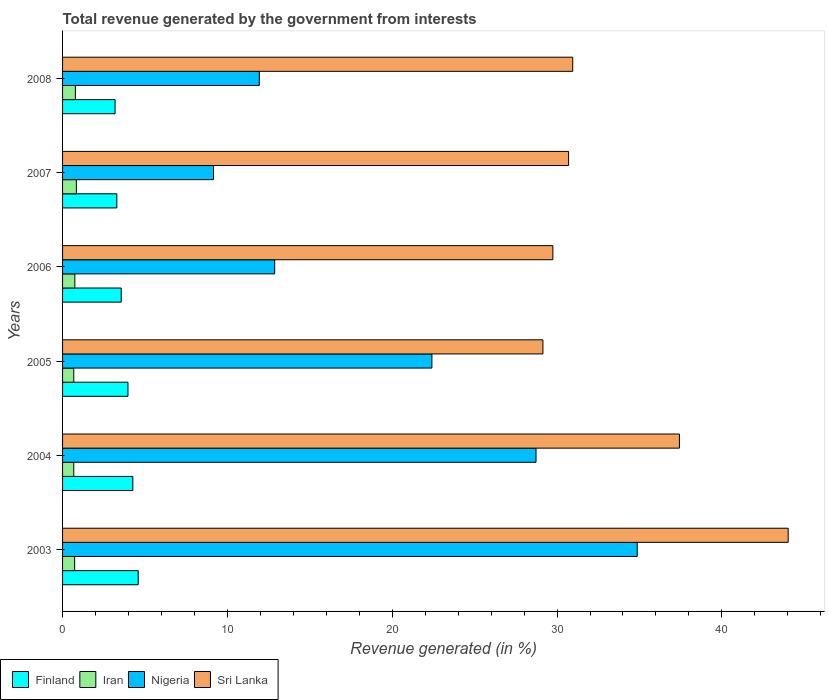How many different coloured bars are there?
Keep it short and to the point. 4. Are the number of bars on each tick of the Y-axis equal?
Give a very brief answer. Yes. How many bars are there on the 1st tick from the bottom?
Provide a short and direct response. 4. What is the total revenue generated in Nigeria in 2007?
Keep it short and to the point. 9.16. Across all years, what is the maximum total revenue generated in Iran?
Offer a terse response. 0.84. Across all years, what is the minimum total revenue generated in Nigeria?
Keep it short and to the point. 9.16. What is the total total revenue generated in Nigeria in the graph?
Offer a very short reply. 119.96. What is the difference between the total revenue generated in Sri Lanka in 2006 and that in 2008?
Your answer should be compact. -1.21. What is the difference between the total revenue generated in Nigeria in 2005 and the total revenue generated in Iran in 2003?
Your response must be concise. 21.67. What is the average total revenue generated in Nigeria per year?
Your response must be concise. 19.99. In the year 2006, what is the difference between the total revenue generated in Nigeria and total revenue generated in Finland?
Your response must be concise. 9.31. In how many years, is the total revenue generated in Nigeria greater than 8 %?
Keep it short and to the point. 6. What is the ratio of the total revenue generated in Finland in 2003 to that in 2005?
Keep it short and to the point. 1.16. Is the total revenue generated in Nigeria in 2004 less than that in 2008?
Provide a short and direct response. No. What is the difference between the highest and the second highest total revenue generated in Iran?
Make the answer very short. 0.06. What is the difference between the highest and the lowest total revenue generated in Finland?
Provide a succinct answer. 1.4. Is the sum of the total revenue generated in Sri Lanka in 2003 and 2007 greater than the maximum total revenue generated in Finland across all years?
Your response must be concise. Yes. Is it the case that in every year, the sum of the total revenue generated in Iran and total revenue generated in Finland is greater than the sum of total revenue generated in Sri Lanka and total revenue generated in Nigeria?
Provide a short and direct response. No. What does the 2nd bar from the top in 2008 represents?
Provide a succinct answer. Nigeria. How many bars are there?
Offer a very short reply. 24. Are all the bars in the graph horizontal?
Give a very brief answer. Yes. How many years are there in the graph?
Your response must be concise. 6. What is the title of the graph?
Offer a terse response. Total revenue generated by the government from interests. Does "Chile" appear as one of the legend labels in the graph?
Offer a terse response. No. What is the label or title of the X-axis?
Give a very brief answer. Revenue generated (in %). What is the label or title of the Y-axis?
Give a very brief answer. Years. What is the Revenue generated (in %) of Finland in 2003?
Provide a succinct answer. 4.59. What is the Revenue generated (in %) in Iran in 2003?
Offer a terse response. 0.73. What is the Revenue generated (in %) of Nigeria in 2003?
Your response must be concise. 34.86. What is the Revenue generated (in %) of Sri Lanka in 2003?
Ensure brevity in your answer.  44.02. What is the Revenue generated (in %) in Finland in 2004?
Provide a short and direct response. 4.26. What is the Revenue generated (in %) of Iran in 2004?
Provide a succinct answer. 0.68. What is the Revenue generated (in %) of Nigeria in 2004?
Ensure brevity in your answer.  28.72. What is the Revenue generated (in %) of Sri Lanka in 2004?
Offer a very short reply. 37.43. What is the Revenue generated (in %) in Finland in 2005?
Make the answer very short. 3.97. What is the Revenue generated (in %) in Iran in 2005?
Give a very brief answer. 0.68. What is the Revenue generated (in %) in Nigeria in 2005?
Your answer should be very brief. 22.41. What is the Revenue generated (in %) of Sri Lanka in 2005?
Give a very brief answer. 29.14. What is the Revenue generated (in %) of Finland in 2006?
Your answer should be very brief. 3.56. What is the Revenue generated (in %) in Iran in 2006?
Provide a succinct answer. 0.75. What is the Revenue generated (in %) in Nigeria in 2006?
Give a very brief answer. 12.87. What is the Revenue generated (in %) in Sri Lanka in 2006?
Your answer should be compact. 29.75. What is the Revenue generated (in %) in Finland in 2007?
Give a very brief answer. 3.29. What is the Revenue generated (in %) of Iran in 2007?
Offer a very short reply. 0.84. What is the Revenue generated (in %) of Nigeria in 2007?
Your answer should be compact. 9.16. What is the Revenue generated (in %) in Sri Lanka in 2007?
Your response must be concise. 30.7. What is the Revenue generated (in %) in Finland in 2008?
Offer a very short reply. 3.19. What is the Revenue generated (in %) in Iran in 2008?
Offer a terse response. 0.78. What is the Revenue generated (in %) of Nigeria in 2008?
Your answer should be compact. 11.94. What is the Revenue generated (in %) in Sri Lanka in 2008?
Provide a short and direct response. 30.95. Across all years, what is the maximum Revenue generated (in %) of Finland?
Ensure brevity in your answer.  4.59. Across all years, what is the maximum Revenue generated (in %) in Iran?
Your answer should be very brief. 0.84. Across all years, what is the maximum Revenue generated (in %) in Nigeria?
Provide a short and direct response. 34.86. Across all years, what is the maximum Revenue generated (in %) in Sri Lanka?
Offer a very short reply. 44.02. Across all years, what is the minimum Revenue generated (in %) of Finland?
Give a very brief answer. 3.19. Across all years, what is the minimum Revenue generated (in %) in Iran?
Your answer should be compact. 0.68. Across all years, what is the minimum Revenue generated (in %) of Nigeria?
Ensure brevity in your answer.  9.16. Across all years, what is the minimum Revenue generated (in %) of Sri Lanka?
Give a very brief answer. 29.14. What is the total Revenue generated (in %) of Finland in the graph?
Your response must be concise. 22.86. What is the total Revenue generated (in %) in Iran in the graph?
Offer a terse response. 4.45. What is the total Revenue generated (in %) in Nigeria in the graph?
Your answer should be compact. 119.96. What is the total Revenue generated (in %) of Sri Lanka in the graph?
Make the answer very short. 201.99. What is the difference between the Revenue generated (in %) of Finland in 2003 and that in 2004?
Your answer should be compact. 0.33. What is the difference between the Revenue generated (in %) of Iran in 2003 and that in 2004?
Give a very brief answer. 0.05. What is the difference between the Revenue generated (in %) of Nigeria in 2003 and that in 2004?
Ensure brevity in your answer.  6.14. What is the difference between the Revenue generated (in %) of Sri Lanka in 2003 and that in 2004?
Give a very brief answer. 6.6. What is the difference between the Revenue generated (in %) of Finland in 2003 and that in 2005?
Keep it short and to the point. 0.62. What is the difference between the Revenue generated (in %) of Iran in 2003 and that in 2005?
Provide a short and direct response. 0.05. What is the difference between the Revenue generated (in %) in Nigeria in 2003 and that in 2005?
Your answer should be very brief. 12.46. What is the difference between the Revenue generated (in %) of Sri Lanka in 2003 and that in 2005?
Provide a short and direct response. 14.88. What is the difference between the Revenue generated (in %) in Finland in 2003 and that in 2006?
Your response must be concise. 1.03. What is the difference between the Revenue generated (in %) of Iran in 2003 and that in 2006?
Provide a short and direct response. -0.01. What is the difference between the Revenue generated (in %) of Nigeria in 2003 and that in 2006?
Your response must be concise. 22. What is the difference between the Revenue generated (in %) of Sri Lanka in 2003 and that in 2006?
Your answer should be compact. 14.28. What is the difference between the Revenue generated (in %) in Finland in 2003 and that in 2007?
Your answer should be very brief. 1.3. What is the difference between the Revenue generated (in %) in Iran in 2003 and that in 2007?
Provide a succinct answer. -0.1. What is the difference between the Revenue generated (in %) in Nigeria in 2003 and that in 2007?
Your answer should be very brief. 25.71. What is the difference between the Revenue generated (in %) in Sri Lanka in 2003 and that in 2007?
Your answer should be compact. 13.32. What is the difference between the Revenue generated (in %) of Finland in 2003 and that in 2008?
Offer a terse response. 1.4. What is the difference between the Revenue generated (in %) of Iran in 2003 and that in 2008?
Offer a very short reply. -0.04. What is the difference between the Revenue generated (in %) of Nigeria in 2003 and that in 2008?
Your response must be concise. 22.93. What is the difference between the Revenue generated (in %) in Sri Lanka in 2003 and that in 2008?
Offer a terse response. 13.07. What is the difference between the Revenue generated (in %) in Finland in 2004 and that in 2005?
Give a very brief answer. 0.29. What is the difference between the Revenue generated (in %) of Iran in 2004 and that in 2005?
Provide a succinct answer. 0. What is the difference between the Revenue generated (in %) of Nigeria in 2004 and that in 2005?
Your answer should be very brief. 6.32. What is the difference between the Revenue generated (in %) of Sri Lanka in 2004 and that in 2005?
Make the answer very short. 8.28. What is the difference between the Revenue generated (in %) in Finland in 2004 and that in 2006?
Give a very brief answer. 0.7. What is the difference between the Revenue generated (in %) of Iran in 2004 and that in 2006?
Make the answer very short. -0.06. What is the difference between the Revenue generated (in %) in Nigeria in 2004 and that in 2006?
Provide a succinct answer. 15.86. What is the difference between the Revenue generated (in %) of Sri Lanka in 2004 and that in 2006?
Your answer should be very brief. 7.68. What is the difference between the Revenue generated (in %) in Finland in 2004 and that in 2007?
Ensure brevity in your answer.  0.97. What is the difference between the Revenue generated (in %) of Iran in 2004 and that in 2007?
Make the answer very short. -0.16. What is the difference between the Revenue generated (in %) of Nigeria in 2004 and that in 2007?
Your response must be concise. 19.57. What is the difference between the Revenue generated (in %) in Sri Lanka in 2004 and that in 2007?
Your response must be concise. 6.72. What is the difference between the Revenue generated (in %) in Finland in 2004 and that in 2008?
Ensure brevity in your answer.  1.08. What is the difference between the Revenue generated (in %) in Iran in 2004 and that in 2008?
Ensure brevity in your answer.  -0.1. What is the difference between the Revenue generated (in %) of Nigeria in 2004 and that in 2008?
Make the answer very short. 16.79. What is the difference between the Revenue generated (in %) of Sri Lanka in 2004 and that in 2008?
Give a very brief answer. 6.47. What is the difference between the Revenue generated (in %) of Finland in 2005 and that in 2006?
Ensure brevity in your answer.  0.41. What is the difference between the Revenue generated (in %) of Iran in 2005 and that in 2006?
Make the answer very short. -0.07. What is the difference between the Revenue generated (in %) in Nigeria in 2005 and that in 2006?
Offer a terse response. 9.54. What is the difference between the Revenue generated (in %) of Sri Lanka in 2005 and that in 2006?
Make the answer very short. -0.6. What is the difference between the Revenue generated (in %) of Finland in 2005 and that in 2007?
Your answer should be very brief. 0.68. What is the difference between the Revenue generated (in %) in Iran in 2005 and that in 2007?
Provide a succinct answer. -0.16. What is the difference between the Revenue generated (in %) of Nigeria in 2005 and that in 2007?
Give a very brief answer. 13.25. What is the difference between the Revenue generated (in %) of Sri Lanka in 2005 and that in 2007?
Your answer should be compact. -1.56. What is the difference between the Revenue generated (in %) in Finland in 2005 and that in 2008?
Offer a terse response. 0.78. What is the difference between the Revenue generated (in %) in Iran in 2005 and that in 2008?
Keep it short and to the point. -0.1. What is the difference between the Revenue generated (in %) in Nigeria in 2005 and that in 2008?
Give a very brief answer. 10.47. What is the difference between the Revenue generated (in %) in Sri Lanka in 2005 and that in 2008?
Your answer should be compact. -1.81. What is the difference between the Revenue generated (in %) in Finland in 2006 and that in 2007?
Provide a succinct answer. 0.27. What is the difference between the Revenue generated (in %) in Iran in 2006 and that in 2007?
Your response must be concise. -0.09. What is the difference between the Revenue generated (in %) of Nigeria in 2006 and that in 2007?
Provide a short and direct response. 3.71. What is the difference between the Revenue generated (in %) in Sri Lanka in 2006 and that in 2007?
Keep it short and to the point. -0.96. What is the difference between the Revenue generated (in %) of Finland in 2006 and that in 2008?
Your response must be concise. 0.37. What is the difference between the Revenue generated (in %) in Iran in 2006 and that in 2008?
Your response must be concise. -0.03. What is the difference between the Revenue generated (in %) in Nigeria in 2006 and that in 2008?
Your answer should be compact. 0.93. What is the difference between the Revenue generated (in %) of Sri Lanka in 2006 and that in 2008?
Keep it short and to the point. -1.21. What is the difference between the Revenue generated (in %) in Finland in 2007 and that in 2008?
Your answer should be compact. 0.11. What is the difference between the Revenue generated (in %) of Iran in 2007 and that in 2008?
Make the answer very short. 0.06. What is the difference between the Revenue generated (in %) in Nigeria in 2007 and that in 2008?
Provide a short and direct response. -2.78. What is the difference between the Revenue generated (in %) of Sri Lanka in 2007 and that in 2008?
Offer a very short reply. -0.25. What is the difference between the Revenue generated (in %) in Finland in 2003 and the Revenue generated (in %) in Iran in 2004?
Offer a very short reply. 3.91. What is the difference between the Revenue generated (in %) in Finland in 2003 and the Revenue generated (in %) in Nigeria in 2004?
Give a very brief answer. -24.13. What is the difference between the Revenue generated (in %) in Finland in 2003 and the Revenue generated (in %) in Sri Lanka in 2004?
Your answer should be compact. -32.84. What is the difference between the Revenue generated (in %) in Iran in 2003 and the Revenue generated (in %) in Nigeria in 2004?
Your answer should be very brief. -27.99. What is the difference between the Revenue generated (in %) in Iran in 2003 and the Revenue generated (in %) in Sri Lanka in 2004?
Your answer should be very brief. -36.69. What is the difference between the Revenue generated (in %) of Nigeria in 2003 and the Revenue generated (in %) of Sri Lanka in 2004?
Ensure brevity in your answer.  -2.56. What is the difference between the Revenue generated (in %) in Finland in 2003 and the Revenue generated (in %) in Iran in 2005?
Offer a very short reply. 3.91. What is the difference between the Revenue generated (in %) of Finland in 2003 and the Revenue generated (in %) of Nigeria in 2005?
Provide a succinct answer. -17.82. What is the difference between the Revenue generated (in %) in Finland in 2003 and the Revenue generated (in %) in Sri Lanka in 2005?
Your answer should be compact. -24.55. What is the difference between the Revenue generated (in %) of Iran in 2003 and the Revenue generated (in %) of Nigeria in 2005?
Ensure brevity in your answer.  -21.67. What is the difference between the Revenue generated (in %) of Iran in 2003 and the Revenue generated (in %) of Sri Lanka in 2005?
Ensure brevity in your answer.  -28.41. What is the difference between the Revenue generated (in %) in Nigeria in 2003 and the Revenue generated (in %) in Sri Lanka in 2005?
Keep it short and to the point. 5.72. What is the difference between the Revenue generated (in %) of Finland in 2003 and the Revenue generated (in %) of Iran in 2006?
Offer a very short reply. 3.84. What is the difference between the Revenue generated (in %) in Finland in 2003 and the Revenue generated (in %) in Nigeria in 2006?
Ensure brevity in your answer.  -8.28. What is the difference between the Revenue generated (in %) of Finland in 2003 and the Revenue generated (in %) of Sri Lanka in 2006?
Provide a short and direct response. -25.16. What is the difference between the Revenue generated (in %) in Iran in 2003 and the Revenue generated (in %) in Nigeria in 2006?
Make the answer very short. -12.14. What is the difference between the Revenue generated (in %) of Iran in 2003 and the Revenue generated (in %) of Sri Lanka in 2006?
Your response must be concise. -29.01. What is the difference between the Revenue generated (in %) in Nigeria in 2003 and the Revenue generated (in %) in Sri Lanka in 2006?
Keep it short and to the point. 5.12. What is the difference between the Revenue generated (in %) of Finland in 2003 and the Revenue generated (in %) of Iran in 2007?
Ensure brevity in your answer.  3.75. What is the difference between the Revenue generated (in %) of Finland in 2003 and the Revenue generated (in %) of Nigeria in 2007?
Ensure brevity in your answer.  -4.57. What is the difference between the Revenue generated (in %) of Finland in 2003 and the Revenue generated (in %) of Sri Lanka in 2007?
Your response must be concise. -26.11. What is the difference between the Revenue generated (in %) of Iran in 2003 and the Revenue generated (in %) of Nigeria in 2007?
Provide a succinct answer. -8.42. What is the difference between the Revenue generated (in %) of Iran in 2003 and the Revenue generated (in %) of Sri Lanka in 2007?
Offer a very short reply. -29.97. What is the difference between the Revenue generated (in %) of Nigeria in 2003 and the Revenue generated (in %) of Sri Lanka in 2007?
Give a very brief answer. 4.16. What is the difference between the Revenue generated (in %) in Finland in 2003 and the Revenue generated (in %) in Iran in 2008?
Make the answer very short. 3.81. What is the difference between the Revenue generated (in %) of Finland in 2003 and the Revenue generated (in %) of Nigeria in 2008?
Give a very brief answer. -7.35. What is the difference between the Revenue generated (in %) of Finland in 2003 and the Revenue generated (in %) of Sri Lanka in 2008?
Give a very brief answer. -26.36. What is the difference between the Revenue generated (in %) in Iran in 2003 and the Revenue generated (in %) in Nigeria in 2008?
Offer a terse response. -11.2. What is the difference between the Revenue generated (in %) of Iran in 2003 and the Revenue generated (in %) of Sri Lanka in 2008?
Make the answer very short. -30.22. What is the difference between the Revenue generated (in %) of Nigeria in 2003 and the Revenue generated (in %) of Sri Lanka in 2008?
Your answer should be compact. 3.91. What is the difference between the Revenue generated (in %) of Finland in 2004 and the Revenue generated (in %) of Iran in 2005?
Keep it short and to the point. 3.58. What is the difference between the Revenue generated (in %) of Finland in 2004 and the Revenue generated (in %) of Nigeria in 2005?
Your answer should be compact. -18.15. What is the difference between the Revenue generated (in %) in Finland in 2004 and the Revenue generated (in %) in Sri Lanka in 2005?
Offer a terse response. -24.88. What is the difference between the Revenue generated (in %) of Iran in 2004 and the Revenue generated (in %) of Nigeria in 2005?
Your answer should be very brief. -21.73. What is the difference between the Revenue generated (in %) of Iran in 2004 and the Revenue generated (in %) of Sri Lanka in 2005?
Give a very brief answer. -28.46. What is the difference between the Revenue generated (in %) in Nigeria in 2004 and the Revenue generated (in %) in Sri Lanka in 2005?
Your answer should be compact. -0.42. What is the difference between the Revenue generated (in %) of Finland in 2004 and the Revenue generated (in %) of Iran in 2006?
Provide a succinct answer. 3.52. What is the difference between the Revenue generated (in %) in Finland in 2004 and the Revenue generated (in %) in Nigeria in 2006?
Make the answer very short. -8.61. What is the difference between the Revenue generated (in %) of Finland in 2004 and the Revenue generated (in %) of Sri Lanka in 2006?
Your answer should be compact. -25.48. What is the difference between the Revenue generated (in %) in Iran in 2004 and the Revenue generated (in %) in Nigeria in 2006?
Make the answer very short. -12.19. What is the difference between the Revenue generated (in %) in Iran in 2004 and the Revenue generated (in %) in Sri Lanka in 2006?
Ensure brevity in your answer.  -29.06. What is the difference between the Revenue generated (in %) of Nigeria in 2004 and the Revenue generated (in %) of Sri Lanka in 2006?
Provide a succinct answer. -1.02. What is the difference between the Revenue generated (in %) in Finland in 2004 and the Revenue generated (in %) in Iran in 2007?
Your response must be concise. 3.43. What is the difference between the Revenue generated (in %) of Finland in 2004 and the Revenue generated (in %) of Nigeria in 2007?
Offer a very short reply. -4.89. What is the difference between the Revenue generated (in %) of Finland in 2004 and the Revenue generated (in %) of Sri Lanka in 2007?
Give a very brief answer. -26.44. What is the difference between the Revenue generated (in %) in Iran in 2004 and the Revenue generated (in %) in Nigeria in 2007?
Your answer should be very brief. -8.48. What is the difference between the Revenue generated (in %) of Iran in 2004 and the Revenue generated (in %) of Sri Lanka in 2007?
Offer a terse response. -30.02. What is the difference between the Revenue generated (in %) of Nigeria in 2004 and the Revenue generated (in %) of Sri Lanka in 2007?
Offer a terse response. -1.98. What is the difference between the Revenue generated (in %) in Finland in 2004 and the Revenue generated (in %) in Iran in 2008?
Your response must be concise. 3.49. What is the difference between the Revenue generated (in %) of Finland in 2004 and the Revenue generated (in %) of Nigeria in 2008?
Offer a terse response. -7.67. What is the difference between the Revenue generated (in %) of Finland in 2004 and the Revenue generated (in %) of Sri Lanka in 2008?
Your answer should be very brief. -26.69. What is the difference between the Revenue generated (in %) in Iran in 2004 and the Revenue generated (in %) in Nigeria in 2008?
Your response must be concise. -11.26. What is the difference between the Revenue generated (in %) of Iran in 2004 and the Revenue generated (in %) of Sri Lanka in 2008?
Offer a very short reply. -30.27. What is the difference between the Revenue generated (in %) in Nigeria in 2004 and the Revenue generated (in %) in Sri Lanka in 2008?
Make the answer very short. -2.23. What is the difference between the Revenue generated (in %) of Finland in 2005 and the Revenue generated (in %) of Iran in 2006?
Make the answer very short. 3.22. What is the difference between the Revenue generated (in %) in Finland in 2005 and the Revenue generated (in %) in Nigeria in 2006?
Provide a succinct answer. -8.9. What is the difference between the Revenue generated (in %) of Finland in 2005 and the Revenue generated (in %) of Sri Lanka in 2006?
Give a very brief answer. -25.78. What is the difference between the Revenue generated (in %) in Iran in 2005 and the Revenue generated (in %) in Nigeria in 2006?
Your answer should be compact. -12.19. What is the difference between the Revenue generated (in %) in Iran in 2005 and the Revenue generated (in %) in Sri Lanka in 2006?
Provide a succinct answer. -29.07. What is the difference between the Revenue generated (in %) of Nigeria in 2005 and the Revenue generated (in %) of Sri Lanka in 2006?
Offer a very short reply. -7.34. What is the difference between the Revenue generated (in %) in Finland in 2005 and the Revenue generated (in %) in Iran in 2007?
Give a very brief answer. 3.13. What is the difference between the Revenue generated (in %) of Finland in 2005 and the Revenue generated (in %) of Nigeria in 2007?
Provide a short and direct response. -5.19. What is the difference between the Revenue generated (in %) of Finland in 2005 and the Revenue generated (in %) of Sri Lanka in 2007?
Your response must be concise. -26.73. What is the difference between the Revenue generated (in %) of Iran in 2005 and the Revenue generated (in %) of Nigeria in 2007?
Keep it short and to the point. -8.48. What is the difference between the Revenue generated (in %) in Iran in 2005 and the Revenue generated (in %) in Sri Lanka in 2007?
Offer a very short reply. -30.02. What is the difference between the Revenue generated (in %) of Nigeria in 2005 and the Revenue generated (in %) of Sri Lanka in 2007?
Your answer should be very brief. -8.29. What is the difference between the Revenue generated (in %) of Finland in 2005 and the Revenue generated (in %) of Iran in 2008?
Offer a terse response. 3.19. What is the difference between the Revenue generated (in %) of Finland in 2005 and the Revenue generated (in %) of Nigeria in 2008?
Offer a very short reply. -7.97. What is the difference between the Revenue generated (in %) in Finland in 2005 and the Revenue generated (in %) in Sri Lanka in 2008?
Your answer should be very brief. -26.98. What is the difference between the Revenue generated (in %) of Iran in 2005 and the Revenue generated (in %) of Nigeria in 2008?
Your answer should be very brief. -11.26. What is the difference between the Revenue generated (in %) of Iran in 2005 and the Revenue generated (in %) of Sri Lanka in 2008?
Your response must be concise. -30.27. What is the difference between the Revenue generated (in %) of Nigeria in 2005 and the Revenue generated (in %) of Sri Lanka in 2008?
Make the answer very short. -8.54. What is the difference between the Revenue generated (in %) of Finland in 2006 and the Revenue generated (in %) of Iran in 2007?
Your answer should be very brief. 2.72. What is the difference between the Revenue generated (in %) in Finland in 2006 and the Revenue generated (in %) in Nigeria in 2007?
Keep it short and to the point. -5.6. What is the difference between the Revenue generated (in %) of Finland in 2006 and the Revenue generated (in %) of Sri Lanka in 2007?
Your response must be concise. -27.14. What is the difference between the Revenue generated (in %) of Iran in 2006 and the Revenue generated (in %) of Nigeria in 2007?
Keep it short and to the point. -8.41. What is the difference between the Revenue generated (in %) in Iran in 2006 and the Revenue generated (in %) in Sri Lanka in 2007?
Provide a succinct answer. -29.96. What is the difference between the Revenue generated (in %) of Nigeria in 2006 and the Revenue generated (in %) of Sri Lanka in 2007?
Offer a terse response. -17.83. What is the difference between the Revenue generated (in %) in Finland in 2006 and the Revenue generated (in %) in Iran in 2008?
Offer a very short reply. 2.78. What is the difference between the Revenue generated (in %) in Finland in 2006 and the Revenue generated (in %) in Nigeria in 2008?
Provide a succinct answer. -8.38. What is the difference between the Revenue generated (in %) in Finland in 2006 and the Revenue generated (in %) in Sri Lanka in 2008?
Your answer should be compact. -27.39. What is the difference between the Revenue generated (in %) of Iran in 2006 and the Revenue generated (in %) of Nigeria in 2008?
Offer a terse response. -11.19. What is the difference between the Revenue generated (in %) of Iran in 2006 and the Revenue generated (in %) of Sri Lanka in 2008?
Make the answer very short. -30.21. What is the difference between the Revenue generated (in %) of Nigeria in 2006 and the Revenue generated (in %) of Sri Lanka in 2008?
Provide a succinct answer. -18.08. What is the difference between the Revenue generated (in %) in Finland in 2007 and the Revenue generated (in %) in Iran in 2008?
Your answer should be compact. 2.52. What is the difference between the Revenue generated (in %) in Finland in 2007 and the Revenue generated (in %) in Nigeria in 2008?
Offer a terse response. -8.64. What is the difference between the Revenue generated (in %) of Finland in 2007 and the Revenue generated (in %) of Sri Lanka in 2008?
Your answer should be very brief. -27.66. What is the difference between the Revenue generated (in %) of Iran in 2007 and the Revenue generated (in %) of Nigeria in 2008?
Provide a short and direct response. -11.1. What is the difference between the Revenue generated (in %) of Iran in 2007 and the Revenue generated (in %) of Sri Lanka in 2008?
Offer a terse response. -30.11. What is the difference between the Revenue generated (in %) of Nigeria in 2007 and the Revenue generated (in %) of Sri Lanka in 2008?
Keep it short and to the point. -21.79. What is the average Revenue generated (in %) of Finland per year?
Your answer should be very brief. 3.81. What is the average Revenue generated (in %) in Iran per year?
Give a very brief answer. 0.74. What is the average Revenue generated (in %) of Nigeria per year?
Offer a terse response. 19.99. What is the average Revenue generated (in %) of Sri Lanka per year?
Your response must be concise. 33.67. In the year 2003, what is the difference between the Revenue generated (in %) in Finland and Revenue generated (in %) in Iran?
Your answer should be very brief. 3.86. In the year 2003, what is the difference between the Revenue generated (in %) of Finland and Revenue generated (in %) of Nigeria?
Your answer should be very brief. -30.27. In the year 2003, what is the difference between the Revenue generated (in %) of Finland and Revenue generated (in %) of Sri Lanka?
Make the answer very short. -39.43. In the year 2003, what is the difference between the Revenue generated (in %) in Iran and Revenue generated (in %) in Nigeria?
Provide a succinct answer. -34.13. In the year 2003, what is the difference between the Revenue generated (in %) of Iran and Revenue generated (in %) of Sri Lanka?
Offer a very short reply. -43.29. In the year 2003, what is the difference between the Revenue generated (in %) of Nigeria and Revenue generated (in %) of Sri Lanka?
Make the answer very short. -9.16. In the year 2004, what is the difference between the Revenue generated (in %) in Finland and Revenue generated (in %) in Iran?
Make the answer very short. 3.58. In the year 2004, what is the difference between the Revenue generated (in %) of Finland and Revenue generated (in %) of Nigeria?
Your answer should be very brief. -24.46. In the year 2004, what is the difference between the Revenue generated (in %) in Finland and Revenue generated (in %) in Sri Lanka?
Your response must be concise. -33.16. In the year 2004, what is the difference between the Revenue generated (in %) in Iran and Revenue generated (in %) in Nigeria?
Offer a terse response. -28.04. In the year 2004, what is the difference between the Revenue generated (in %) in Iran and Revenue generated (in %) in Sri Lanka?
Offer a very short reply. -36.75. In the year 2004, what is the difference between the Revenue generated (in %) in Nigeria and Revenue generated (in %) in Sri Lanka?
Give a very brief answer. -8.7. In the year 2005, what is the difference between the Revenue generated (in %) in Finland and Revenue generated (in %) in Iran?
Offer a terse response. 3.29. In the year 2005, what is the difference between the Revenue generated (in %) of Finland and Revenue generated (in %) of Nigeria?
Keep it short and to the point. -18.44. In the year 2005, what is the difference between the Revenue generated (in %) in Finland and Revenue generated (in %) in Sri Lanka?
Offer a terse response. -25.17. In the year 2005, what is the difference between the Revenue generated (in %) of Iran and Revenue generated (in %) of Nigeria?
Offer a terse response. -21.73. In the year 2005, what is the difference between the Revenue generated (in %) in Iran and Revenue generated (in %) in Sri Lanka?
Provide a short and direct response. -28.46. In the year 2005, what is the difference between the Revenue generated (in %) of Nigeria and Revenue generated (in %) of Sri Lanka?
Make the answer very short. -6.74. In the year 2006, what is the difference between the Revenue generated (in %) of Finland and Revenue generated (in %) of Iran?
Give a very brief answer. 2.81. In the year 2006, what is the difference between the Revenue generated (in %) of Finland and Revenue generated (in %) of Nigeria?
Your answer should be compact. -9.31. In the year 2006, what is the difference between the Revenue generated (in %) of Finland and Revenue generated (in %) of Sri Lanka?
Your answer should be compact. -26.19. In the year 2006, what is the difference between the Revenue generated (in %) in Iran and Revenue generated (in %) in Nigeria?
Provide a short and direct response. -12.12. In the year 2006, what is the difference between the Revenue generated (in %) of Iran and Revenue generated (in %) of Sri Lanka?
Ensure brevity in your answer.  -29. In the year 2006, what is the difference between the Revenue generated (in %) of Nigeria and Revenue generated (in %) of Sri Lanka?
Give a very brief answer. -16.88. In the year 2007, what is the difference between the Revenue generated (in %) of Finland and Revenue generated (in %) of Iran?
Provide a succinct answer. 2.45. In the year 2007, what is the difference between the Revenue generated (in %) of Finland and Revenue generated (in %) of Nigeria?
Your answer should be very brief. -5.87. In the year 2007, what is the difference between the Revenue generated (in %) of Finland and Revenue generated (in %) of Sri Lanka?
Provide a succinct answer. -27.41. In the year 2007, what is the difference between the Revenue generated (in %) in Iran and Revenue generated (in %) in Nigeria?
Make the answer very short. -8.32. In the year 2007, what is the difference between the Revenue generated (in %) in Iran and Revenue generated (in %) in Sri Lanka?
Offer a very short reply. -29.86. In the year 2007, what is the difference between the Revenue generated (in %) in Nigeria and Revenue generated (in %) in Sri Lanka?
Ensure brevity in your answer.  -21.54. In the year 2008, what is the difference between the Revenue generated (in %) of Finland and Revenue generated (in %) of Iran?
Keep it short and to the point. 2.41. In the year 2008, what is the difference between the Revenue generated (in %) of Finland and Revenue generated (in %) of Nigeria?
Ensure brevity in your answer.  -8.75. In the year 2008, what is the difference between the Revenue generated (in %) of Finland and Revenue generated (in %) of Sri Lanka?
Make the answer very short. -27.77. In the year 2008, what is the difference between the Revenue generated (in %) of Iran and Revenue generated (in %) of Nigeria?
Ensure brevity in your answer.  -11.16. In the year 2008, what is the difference between the Revenue generated (in %) of Iran and Revenue generated (in %) of Sri Lanka?
Ensure brevity in your answer.  -30.18. In the year 2008, what is the difference between the Revenue generated (in %) of Nigeria and Revenue generated (in %) of Sri Lanka?
Offer a very short reply. -19.01. What is the ratio of the Revenue generated (in %) in Finland in 2003 to that in 2004?
Offer a terse response. 1.08. What is the ratio of the Revenue generated (in %) in Iran in 2003 to that in 2004?
Offer a very short reply. 1.08. What is the ratio of the Revenue generated (in %) of Nigeria in 2003 to that in 2004?
Make the answer very short. 1.21. What is the ratio of the Revenue generated (in %) in Sri Lanka in 2003 to that in 2004?
Your response must be concise. 1.18. What is the ratio of the Revenue generated (in %) of Finland in 2003 to that in 2005?
Offer a very short reply. 1.16. What is the ratio of the Revenue generated (in %) of Iran in 2003 to that in 2005?
Ensure brevity in your answer.  1.08. What is the ratio of the Revenue generated (in %) in Nigeria in 2003 to that in 2005?
Provide a short and direct response. 1.56. What is the ratio of the Revenue generated (in %) of Sri Lanka in 2003 to that in 2005?
Ensure brevity in your answer.  1.51. What is the ratio of the Revenue generated (in %) of Finland in 2003 to that in 2006?
Your answer should be compact. 1.29. What is the ratio of the Revenue generated (in %) in Iran in 2003 to that in 2006?
Provide a succinct answer. 0.98. What is the ratio of the Revenue generated (in %) of Nigeria in 2003 to that in 2006?
Your response must be concise. 2.71. What is the ratio of the Revenue generated (in %) in Sri Lanka in 2003 to that in 2006?
Your response must be concise. 1.48. What is the ratio of the Revenue generated (in %) of Finland in 2003 to that in 2007?
Your answer should be very brief. 1.39. What is the ratio of the Revenue generated (in %) of Iran in 2003 to that in 2007?
Your answer should be compact. 0.88. What is the ratio of the Revenue generated (in %) in Nigeria in 2003 to that in 2007?
Your answer should be very brief. 3.81. What is the ratio of the Revenue generated (in %) in Sri Lanka in 2003 to that in 2007?
Your answer should be compact. 1.43. What is the ratio of the Revenue generated (in %) of Finland in 2003 to that in 2008?
Your answer should be compact. 1.44. What is the ratio of the Revenue generated (in %) in Iran in 2003 to that in 2008?
Ensure brevity in your answer.  0.95. What is the ratio of the Revenue generated (in %) of Nigeria in 2003 to that in 2008?
Offer a very short reply. 2.92. What is the ratio of the Revenue generated (in %) in Sri Lanka in 2003 to that in 2008?
Ensure brevity in your answer.  1.42. What is the ratio of the Revenue generated (in %) in Finland in 2004 to that in 2005?
Ensure brevity in your answer.  1.07. What is the ratio of the Revenue generated (in %) of Iran in 2004 to that in 2005?
Provide a succinct answer. 1. What is the ratio of the Revenue generated (in %) in Nigeria in 2004 to that in 2005?
Provide a short and direct response. 1.28. What is the ratio of the Revenue generated (in %) in Sri Lanka in 2004 to that in 2005?
Offer a very short reply. 1.28. What is the ratio of the Revenue generated (in %) in Finland in 2004 to that in 2006?
Offer a terse response. 1.2. What is the ratio of the Revenue generated (in %) in Iran in 2004 to that in 2006?
Keep it short and to the point. 0.91. What is the ratio of the Revenue generated (in %) in Nigeria in 2004 to that in 2006?
Keep it short and to the point. 2.23. What is the ratio of the Revenue generated (in %) of Sri Lanka in 2004 to that in 2006?
Offer a very short reply. 1.26. What is the ratio of the Revenue generated (in %) in Finland in 2004 to that in 2007?
Provide a succinct answer. 1.29. What is the ratio of the Revenue generated (in %) in Iran in 2004 to that in 2007?
Offer a very short reply. 0.81. What is the ratio of the Revenue generated (in %) of Nigeria in 2004 to that in 2007?
Make the answer very short. 3.14. What is the ratio of the Revenue generated (in %) in Sri Lanka in 2004 to that in 2007?
Make the answer very short. 1.22. What is the ratio of the Revenue generated (in %) in Finland in 2004 to that in 2008?
Your response must be concise. 1.34. What is the ratio of the Revenue generated (in %) in Iran in 2004 to that in 2008?
Offer a very short reply. 0.88. What is the ratio of the Revenue generated (in %) of Nigeria in 2004 to that in 2008?
Provide a short and direct response. 2.41. What is the ratio of the Revenue generated (in %) in Sri Lanka in 2004 to that in 2008?
Provide a succinct answer. 1.21. What is the ratio of the Revenue generated (in %) of Finland in 2005 to that in 2006?
Keep it short and to the point. 1.12. What is the ratio of the Revenue generated (in %) of Iran in 2005 to that in 2006?
Give a very brief answer. 0.91. What is the ratio of the Revenue generated (in %) in Nigeria in 2005 to that in 2006?
Offer a terse response. 1.74. What is the ratio of the Revenue generated (in %) in Sri Lanka in 2005 to that in 2006?
Provide a succinct answer. 0.98. What is the ratio of the Revenue generated (in %) in Finland in 2005 to that in 2007?
Ensure brevity in your answer.  1.21. What is the ratio of the Revenue generated (in %) of Iran in 2005 to that in 2007?
Provide a succinct answer. 0.81. What is the ratio of the Revenue generated (in %) in Nigeria in 2005 to that in 2007?
Offer a terse response. 2.45. What is the ratio of the Revenue generated (in %) of Sri Lanka in 2005 to that in 2007?
Your answer should be very brief. 0.95. What is the ratio of the Revenue generated (in %) in Finland in 2005 to that in 2008?
Make the answer very short. 1.25. What is the ratio of the Revenue generated (in %) in Iran in 2005 to that in 2008?
Your response must be concise. 0.88. What is the ratio of the Revenue generated (in %) in Nigeria in 2005 to that in 2008?
Ensure brevity in your answer.  1.88. What is the ratio of the Revenue generated (in %) in Sri Lanka in 2005 to that in 2008?
Provide a short and direct response. 0.94. What is the ratio of the Revenue generated (in %) of Finland in 2006 to that in 2007?
Offer a very short reply. 1.08. What is the ratio of the Revenue generated (in %) in Iran in 2006 to that in 2007?
Offer a terse response. 0.89. What is the ratio of the Revenue generated (in %) in Nigeria in 2006 to that in 2007?
Make the answer very short. 1.41. What is the ratio of the Revenue generated (in %) of Sri Lanka in 2006 to that in 2007?
Give a very brief answer. 0.97. What is the ratio of the Revenue generated (in %) of Finland in 2006 to that in 2008?
Give a very brief answer. 1.12. What is the ratio of the Revenue generated (in %) of Iran in 2006 to that in 2008?
Give a very brief answer. 0.96. What is the ratio of the Revenue generated (in %) of Nigeria in 2006 to that in 2008?
Ensure brevity in your answer.  1.08. What is the ratio of the Revenue generated (in %) in Finland in 2007 to that in 2008?
Offer a terse response. 1.03. What is the ratio of the Revenue generated (in %) in Iran in 2007 to that in 2008?
Give a very brief answer. 1.08. What is the ratio of the Revenue generated (in %) in Nigeria in 2007 to that in 2008?
Keep it short and to the point. 0.77. What is the ratio of the Revenue generated (in %) of Sri Lanka in 2007 to that in 2008?
Ensure brevity in your answer.  0.99. What is the difference between the highest and the second highest Revenue generated (in %) of Finland?
Make the answer very short. 0.33. What is the difference between the highest and the second highest Revenue generated (in %) in Iran?
Give a very brief answer. 0.06. What is the difference between the highest and the second highest Revenue generated (in %) in Nigeria?
Ensure brevity in your answer.  6.14. What is the difference between the highest and the second highest Revenue generated (in %) of Sri Lanka?
Keep it short and to the point. 6.6. What is the difference between the highest and the lowest Revenue generated (in %) in Finland?
Give a very brief answer. 1.4. What is the difference between the highest and the lowest Revenue generated (in %) of Iran?
Offer a terse response. 0.16. What is the difference between the highest and the lowest Revenue generated (in %) in Nigeria?
Offer a terse response. 25.71. What is the difference between the highest and the lowest Revenue generated (in %) in Sri Lanka?
Offer a terse response. 14.88. 